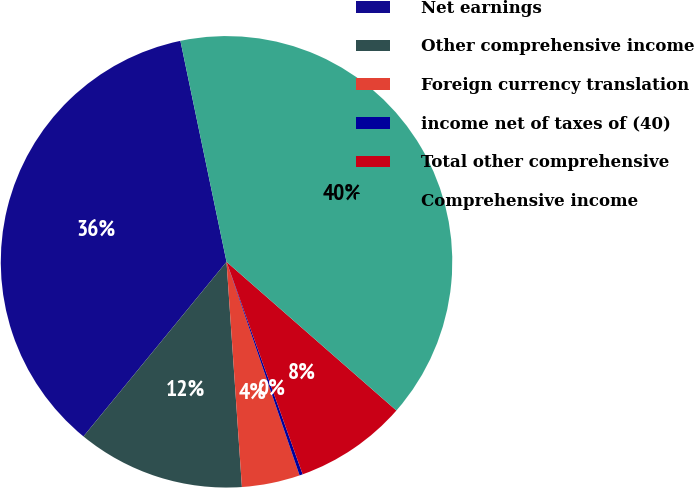Convert chart to OTSL. <chart><loc_0><loc_0><loc_500><loc_500><pie_chart><fcel>Net earnings<fcel>Other comprehensive income<fcel>Foreign currency translation<fcel>income net of taxes of (40)<fcel>Total other comprehensive<fcel>Comprehensive income<nl><fcel>35.8%<fcel>12.01%<fcel>4.16%<fcel>0.23%<fcel>8.08%<fcel>39.72%<nl></chart> 